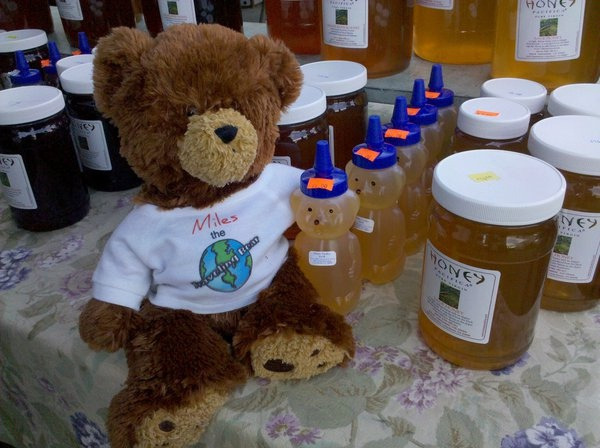Describe the objects in this image and their specific colors. I can see teddy bear in black, maroon, and darkgray tones, bottle in black, maroon, gray, and lavender tones, bottle in black, darkgray, and gray tones, bottle in black, darkgray, maroon, lavender, and gray tones, and bottle in black, olive, and darkgray tones in this image. 